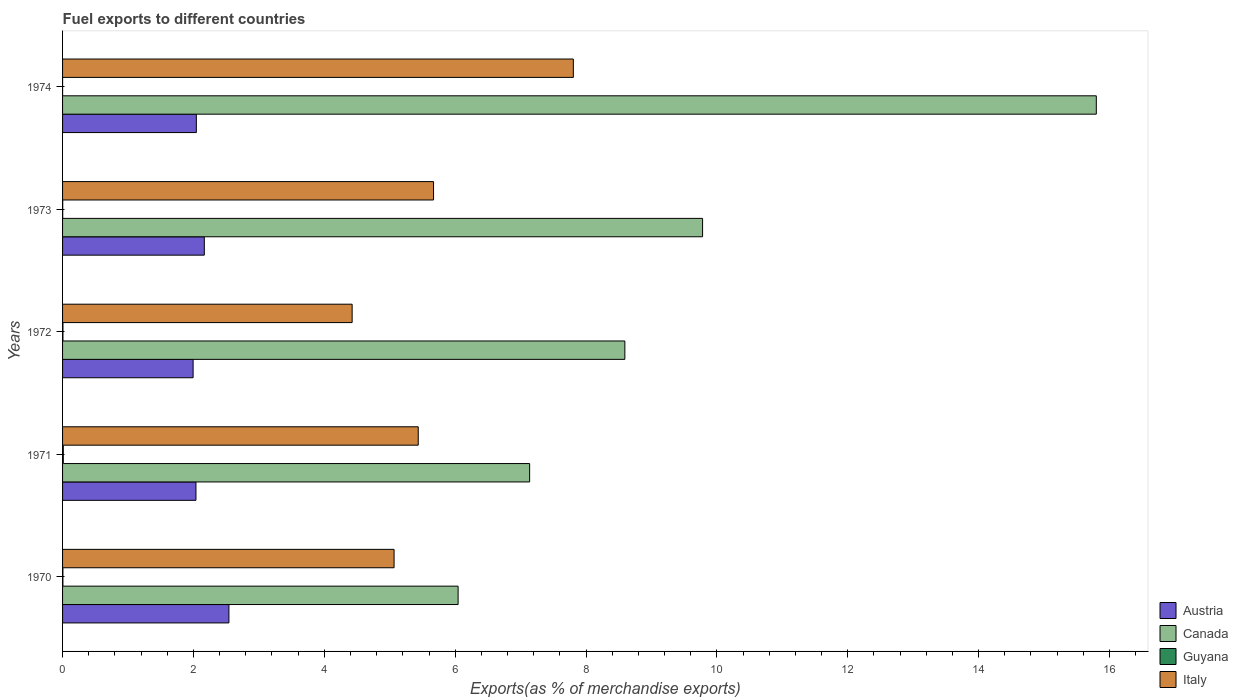How many bars are there on the 5th tick from the bottom?
Provide a succinct answer. 4. What is the percentage of exports to different countries in Austria in 1970?
Provide a succinct answer. 2.54. Across all years, what is the maximum percentage of exports to different countries in Canada?
Your answer should be very brief. 15.8. Across all years, what is the minimum percentage of exports to different countries in Italy?
Your answer should be compact. 4.43. In which year was the percentage of exports to different countries in Canada maximum?
Your response must be concise. 1974. What is the total percentage of exports to different countries in Guyana in the graph?
Keep it short and to the point. 0.02. What is the difference between the percentage of exports to different countries in Austria in 1972 and that in 1973?
Offer a very short reply. -0.17. What is the difference between the percentage of exports to different countries in Canada in 1974 and the percentage of exports to different countries in Italy in 1972?
Your answer should be compact. 11.37. What is the average percentage of exports to different countries in Austria per year?
Make the answer very short. 2.16. In the year 1973, what is the difference between the percentage of exports to different countries in Canada and percentage of exports to different countries in Austria?
Offer a terse response. 7.61. What is the ratio of the percentage of exports to different countries in Guyana in 1972 to that in 1973?
Provide a short and direct response. 2.67. Is the difference between the percentage of exports to different countries in Canada in 1972 and 1974 greater than the difference between the percentage of exports to different countries in Austria in 1972 and 1974?
Offer a terse response. No. What is the difference between the highest and the second highest percentage of exports to different countries in Italy?
Keep it short and to the point. 2.14. What is the difference between the highest and the lowest percentage of exports to different countries in Austria?
Provide a short and direct response. 0.55. Is the sum of the percentage of exports to different countries in Canada in 1971 and 1974 greater than the maximum percentage of exports to different countries in Guyana across all years?
Your answer should be compact. Yes. Is it the case that in every year, the sum of the percentage of exports to different countries in Canada and percentage of exports to different countries in Austria is greater than the sum of percentage of exports to different countries in Italy and percentage of exports to different countries in Guyana?
Your answer should be compact. Yes. What does the 4th bar from the top in 1974 represents?
Ensure brevity in your answer.  Austria. Is it the case that in every year, the sum of the percentage of exports to different countries in Austria and percentage of exports to different countries in Canada is greater than the percentage of exports to different countries in Italy?
Provide a succinct answer. Yes. How many bars are there?
Your answer should be compact. 20. Are all the bars in the graph horizontal?
Your answer should be compact. Yes. How many years are there in the graph?
Offer a terse response. 5. What is the difference between two consecutive major ticks on the X-axis?
Provide a short and direct response. 2. Does the graph contain any zero values?
Your response must be concise. No. Does the graph contain grids?
Make the answer very short. No. How are the legend labels stacked?
Your answer should be very brief. Vertical. What is the title of the graph?
Make the answer very short. Fuel exports to different countries. What is the label or title of the X-axis?
Your answer should be compact. Exports(as % of merchandise exports). What is the Exports(as % of merchandise exports) of Austria in 1970?
Keep it short and to the point. 2.54. What is the Exports(as % of merchandise exports) in Canada in 1970?
Provide a succinct answer. 6.04. What is the Exports(as % of merchandise exports) of Guyana in 1970?
Provide a succinct answer. 0.01. What is the Exports(as % of merchandise exports) in Italy in 1970?
Your answer should be compact. 5.07. What is the Exports(as % of merchandise exports) in Austria in 1971?
Keep it short and to the point. 2.04. What is the Exports(as % of merchandise exports) in Canada in 1971?
Provide a short and direct response. 7.14. What is the Exports(as % of merchandise exports) in Guyana in 1971?
Provide a succinct answer. 0.01. What is the Exports(as % of merchandise exports) of Italy in 1971?
Your response must be concise. 5.44. What is the Exports(as % of merchandise exports) of Austria in 1972?
Offer a very short reply. 1.99. What is the Exports(as % of merchandise exports) in Canada in 1972?
Offer a terse response. 8.59. What is the Exports(as % of merchandise exports) in Guyana in 1972?
Your answer should be very brief. 0.01. What is the Exports(as % of merchandise exports) of Italy in 1972?
Offer a terse response. 4.43. What is the Exports(as % of merchandise exports) in Austria in 1973?
Ensure brevity in your answer.  2.17. What is the Exports(as % of merchandise exports) in Canada in 1973?
Offer a very short reply. 9.78. What is the Exports(as % of merchandise exports) of Guyana in 1973?
Your response must be concise. 0. What is the Exports(as % of merchandise exports) of Italy in 1973?
Your answer should be compact. 5.67. What is the Exports(as % of merchandise exports) in Austria in 1974?
Your answer should be compact. 2.04. What is the Exports(as % of merchandise exports) in Canada in 1974?
Ensure brevity in your answer.  15.8. What is the Exports(as % of merchandise exports) of Guyana in 1974?
Provide a succinct answer. 0. What is the Exports(as % of merchandise exports) of Italy in 1974?
Offer a terse response. 7.81. Across all years, what is the maximum Exports(as % of merchandise exports) in Austria?
Your answer should be very brief. 2.54. Across all years, what is the maximum Exports(as % of merchandise exports) in Canada?
Offer a very short reply. 15.8. Across all years, what is the maximum Exports(as % of merchandise exports) in Guyana?
Give a very brief answer. 0.01. Across all years, what is the maximum Exports(as % of merchandise exports) of Italy?
Offer a terse response. 7.81. Across all years, what is the minimum Exports(as % of merchandise exports) of Austria?
Keep it short and to the point. 1.99. Across all years, what is the minimum Exports(as % of merchandise exports) of Canada?
Keep it short and to the point. 6.04. Across all years, what is the minimum Exports(as % of merchandise exports) in Guyana?
Make the answer very short. 0. Across all years, what is the minimum Exports(as % of merchandise exports) in Italy?
Make the answer very short. 4.43. What is the total Exports(as % of merchandise exports) in Austria in the graph?
Provide a short and direct response. 10.79. What is the total Exports(as % of merchandise exports) of Canada in the graph?
Ensure brevity in your answer.  47.36. What is the total Exports(as % of merchandise exports) in Guyana in the graph?
Make the answer very short. 0.02. What is the total Exports(as % of merchandise exports) of Italy in the graph?
Make the answer very short. 28.4. What is the difference between the Exports(as % of merchandise exports) in Austria in 1970 and that in 1971?
Your answer should be compact. 0.5. What is the difference between the Exports(as % of merchandise exports) in Canada in 1970 and that in 1971?
Your answer should be very brief. -1.09. What is the difference between the Exports(as % of merchandise exports) in Guyana in 1970 and that in 1971?
Offer a very short reply. -0.01. What is the difference between the Exports(as % of merchandise exports) of Italy in 1970 and that in 1971?
Your answer should be compact. -0.37. What is the difference between the Exports(as % of merchandise exports) of Austria in 1970 and that in 1972?
Offer a very short reply. 0.55. What is the difference between the Exports(as % of merchandise exports) in Canada in 1970 and that in 1972?
Ensure brevity in your answer.  -2.55. What is the difference between the Exports(as % of merchandise exports) in Guyana in 1970 and that in 1972?
Your answer should be compact. -0. What is the difference between the Exports(as % of merchandise exports) in Italy in 1970 and that in 1972?
Provide a succinct answer. 0.64. What is the difference between the Exports(as % of merchandise exports) of Austria in 1970 and that in 1973?
Ensure brevity in your answer.  0.38. What is the difference between the Exports(as % of merchandise exports) of Canada in 1970 and that in 1973?
Give a very brief answer. -3.74. What is the difference between the Exports(as % of merchandise exports) of Guyana in 1970 and that in 1973?
Your answer should be compact. 0. What is the difference between the Exports(as % of merchandise exports) in Italy in 1970 and that in 1973?
Offer a very short reply. -0.6. What is the difference between the Exports(as % of merchandise exports) in Austria in 1970 and that in 1974?
Make the answer very short. 0.5. What is the difference between the Exports(as % of merchandise exports) in Canada in 1970 and that in 1974?
Offer a terse response. -9.75. What is the difference between the Exports(as % of merchandise exports) of Guyana in 1970 and that in 1974?
Give a very brief answer. 0.01. What is the difference between the Exports(as % of merchandise exports) in Italy in 1970 and that in 1974?
Ensure brevity in your answer.  -2.74. What is the difference between the Exports(as % of merchandise exports) in Austria in 1971 and that in 1972?
Provide a succinct answer. 0.04. What is the difference between the Exports(as % of merchandise exports) in Canada in 1971 and that in 1972?
Provide a short and direct response. -1.46. What is the difference between the Exports(as % of merchandise exports) of Guyana in 1971 and that in 1972?
Give a very brief answer. 0.01. What is the difference between the Exports(as % of merchandise exports) of Italy in 1971 and that in 1972?
Keep it short and to the point. 1.01. What is the difference between the Exports(as % of merchandise exports) of Austria in 1971 and that in 1973?
Ensure brevity in your answer.  -0.13. What is the difference between the Exports(as % of merchandise exports) of Canada in 1971 and that in 1973?
Provide a short and direct response. -2.64. What is the difference between the Exports(as % of merchandise exports) in Guyana in 1971 and that in 1973?
Your answer should be very brief. 0.01. What is the difference between the Exports(as % of merchandise exports) of Italy in 1971 and that in 1973?
Provide a short and direct response. -0.23. What is the difference between the Exports(as % of merchandise exports) of Austria in 1971 and that in 1974?
Ensure brevity in your answer.  -0.01. What is the difference between the Exports(as % of merchandise exports) of Canada in 1971 and that in 1974?
Provide a succinct answer. -8.66. What is the difference between the Exports(as % of merchandise exports) in Guyana in 1971 and that in 1974?
Offer a very short reply. 0.01. What is the difference between the Exports(as % of merchandise exports) of Italy in 1971 and that in 1974?
Your answer should be very brief. -2.37. What is the difference between the Exports(as % of merchandise exports) of Austria in 1972 and that in 1973?
Ensure brevity in your answer.  -0.17. What is the difference between the Exports(as % of merchandise exports) in Canada in 1972 and that in 1973?
Provide a short and direct response. -1.19. What is the difference between the Exports(as % of merchandise exports) in Guyana in 1972 and that in 1973?
Provide a succinct answer. 0. What is the difference between the Exports(as % of merchandise exports) in Italy in 1972 and that in 1973?
Keep it short and to the point. -1.24. What is the difference between the Exports(as % of merchandise exports) in Austria in 1972 and that in 1974?
Make the answer very short. -0.05. What is the difference between the Exports(as % of merchandise exports) in Canada in 1972 and that in 1974?
Your answer should be very brief. -7.21. What is the difference between the Exports(as % of merchandise exports) in Guyana in 1972 and that in 1974?
Provide a succinct answer. 0.01. What is the difference between the Exports(as % of merchandise exports) of Italy in 1972 and that in 1974?
Provide a short and direct response. -3.38. What is the difference between the Exports(as % of merchandise exports) in Austria in 1973 and that in 1974?
Your response must be concise. 0.12. What is the difference between the Exports(as % of merchandise exports) in Canada in 1973 and that in 1974?
Give a very brief answer. -6.02. What is the difference between the Exports(as % of merchandise exports) of Guyana in 1973 and that in 1974?
Give a very brief answer. 0. What is the difference between the Exports(as % of merchandise exports) of Italy in 1973 and that in 1974?
Offer a terse response. -2.14. What is the difference between the Exports(as % of merchandise exports) in Austria in 1970 and the Exports(as % of merchandise exports) in Canada in 1971?
Ensure brevity in your answer.  -4.6. What is the difference between the Exports(as % of merchandise exports) in Austria in 1970 and the Exports(as % of merchandise exports) in Guyana in 1971?
Make the answer very short. 2.53. What is the difference between the Exports(as % of merchandise exports) in Austria in 1970 and the Exports(as % of merchandise exports) in Italy in 1971?
Your answer should be compact. -2.89. What is the difference between the Exports(as % of merchandise exports) of Canada in 1970 and the Exports(as % of merchandise exports) of Guyana in 1971?
Give a very brief answer. 6.03. What is the difference between the Exports(as % of merchandise exports) in Canada in 1970 and the Exports(as % of merchandise exports) in Italy in 1971?
Your response must be concise. 0.61. What is the difference between the Exports(as % of merchandise exports) in Guyana in 1970 and the Exports(as % of merchandise exports) in Italy in 1971?
Offer a very short reply. -5.43. What is the difference between the Exports(as % of merchandise exports) of Austria in 1970 and the Exports(as % of merchandise exports) of Canada in 1972?
Provide a succinct answer. -6.05. What is the difference between the Exports(as % of merchandise exports) in Austria in 1970 and the Exports(as % of merchandise exports) in Guyana in 1972?
Ensure brevity in your answer.  2.54. What is the difference between the Exports(as % of merchandise exports) in Austria in 1970 and the Exports(as % of merchandise exports) in Italy in 1972?
Offer a terse response. -1.88. What is the difference between the Exports(as % of merchandise exports) of Canada in 1970 and the Exports(as % of merchandise exports) of Guyana in 1972?
Offer a very short reply. 6.04. What is the difference between the Exports(as % of merchandise exports) in Canada in 1970 and the Exports(as % of merchandise exports) in Italy in 1972?
Offer a terse response. 1.62. What is the difference between the Exports(as % of merchandise exports) in Guyana in 1970 and the Exports(as % of merchandise exports) in Italy in 1972?
Provide a succinct answer. -4.42. What is the difference between the Exports(as % of merchandise exports) of Austria in 1970 and the Exports(as % of merchandise exports) of Canada in 1973?
Provide a short and direct response. -7.24. What is the difference between the Exports(as % of merchandise exports) in Austria in 1970 and the Exports(as % of merchandise exports) in Guyana in 1973?
Ensure brevity in your answer.  2.54. What is the difference between the Exports(as % of merchandise exports) of Austria in 1970 and the Exports(as % of merchandise exports) of Italy in 1973?
Offer a very short reply. -3.13. What is the difference between the Exports(as % of merchandise exports) in Canada in 1970 and the Exports(as % of merchandise exports) in Guyana in 1973?
Make the answer very short. 6.04. What is the difference between the Exports(as % of merchandise exports) in Canada in 1970 and the Exports(as % of merchandise exports) in Italy in 1973?
Keep it short and to the point. 0.38. What is the difference between the Exports(as % of merchandise exports) of Guyana in 1970 and the Exports(as % of merchandise exports) of Italy in 1973?
Offer a very short reply. -5.66. What is the difference between the Exports(as % of merchandise exports) of Austria in 1970 and the Exports(as % of merchandise exports) of Canada in 1974?
Provide a succinct answer. -13.26. What is the difference between the Exports(as % of merchandise exports) in Austria in 1970 and the Exports(as % of merchandise exports) in Guyana in 1974?
Make the answer very short. 2.54. What is the difference between the Exports(as % of merchandise exports) of Austria in 1970 and the Exports(as % of merchandise exports) of Italy in 1974?
Offer a very short reply. -5.26. What is the difference between the Exports(as % of merchandise exports) in Canada in 1970 and the Exports(as % of merchandise exports) in Guyana in 1974?
Provide a succinct answer. 6.04. What is the difference between the Exports(as % of merchandise exports) in Canada in 1970 and the Exports(as % of merchandise exports) in Italy in 1974?
Keep it short and to the point. -1.76. What is the difference between the Exports(as % of merchandise exports) in Guyana in 1970 and the Exports(as % of merchandise exports) in Italy in 1974?
Offer a very short reply. -7.8. What is the difference between the Exports(as % of merchandise exports) in Austria in 1971 and the Exports(as % of merchandise exports) in Canada in 1972?
Offer a terse response. -6.55. What is the difference between the Exports(as % of merchandise exports) of Austria in 1971 and the Exports(as % of merchandise exports) of Guyana in 1972?
Provide a short and direct response. 2.03. What is the difference between the Exports(as % of merchandise exports) in Austria in 1971 and the Exports(as % of merchandise exports) in Italy in 1972?
Offer a very short reply. -2.39. What is the difference between the Exports(as % of merchandise exports) in Canada in 1971 and the Exports(as % of merchandise exports) in Guyana in 1972?
Offer a terse response. 7.13. What is the difference between the Exports(as % of merchandise exports) in Canada in 1971 and the Exports(as % of merchandise exports) in Italy in 1972?
Your answer should be very brief. 2.71. What is the difference between the Exports(as % of merchandise exports) in Guyana in 1971 and the Exports(as % of merchandise exports) in Italy in 1972?
Ensure brevity in your answer.  -4.41. What is the difference between the Exports(as % of merchandise exports) in Austria in 1971 and the Exports(as % of merchandise exports) in Canada in 1973?
Provide a succinct answer. -7.74. What is the difference between the Exports(as % of merchandise exports) of Austria in 1971 and the Exports(as % of merchandise exports) of Guyana in 1973?
Ensure brevity in your answer.  2.04. What is the difference between the Exports(as % of merchandise exports) of Austria in 1971 and the Exports(as % of merchandise exports) of Italy in 1973?
Offer a terse response. -3.63. What is the difference between the Exports(as % of merchandise exports) in Canada in 1971 and the Exports(as % of merchandise exports) in Guyana in 1973?
Ensure brevity in your answer.  7.14. What is the difference between the Exports(as % of merchandise exports) of Canada in 1971 and the Exports(as % of merchandise exports) of Italy in 1973?
Keep it short and to the point. 1.47. What is the difference between the Exports(as % of merchandise exports) of Guyana in 1971 and the Exports(as % of merchandise exports) of Italy in 1973?
Your answer should be compact. -5.66. What is the difference between the Exports(as % of merchandise exports) in Austria in 1971 and the Exports(as % of merchandise exports) in Canada in 1974?
Keep it short and to the point. -13.76. What is the difference between the Exports(as % of merchandise exports) in Austria in 1971 and the Exports(as % of merchandise exports) in Guyana in 1974?
Provide a short and direct response. 2.04. What is the difference between the Exports(as % of merchandise exports) in Austria in 1971 and the Exports(as % of merchandise exports) in Italy in 1974?
Your answer should be compact. -5.77. What is the difference between the Exports(as % of merchandise exports) of Canada in 1971 and the Exports(as % of merchandise exports) of Guyana in 1974?
Keep it short and to the point. 7.14. What is the difference between the Exports(as % of merchandise exports) in Canada in 1971 and the Exports(as % of merchandise exports) in Italy in 1974?
Make the answer very short. -0.67. What is the difference between the Exports(as % of merchandise exports) in Guyana in 1971 and the Exports(as % of merchandise exports) in Italy in 1974?
Your answer should be compact. -7.79. What is the difference between the Exports(as % of merchandise exports) of Austria in 1972 and the Exports(as % of merchandise exports) of Canada in 1973?
Offer a very short reply. -7.79. What is the difference between the Exports(as % of merchandise exports) of Austria in 1972 and the Exports(as % of merchandise exports) of Guyana in 1973?
Keep it short and to the point. 1.99. What is the difference between the Exports(as % of merchandise exports) of Austria in 1972 and the Exports(as % of merchandise exports) of Italy in 1973?
Your answer should be compact. -3.67. What is the difference between the Exports(as % of merchandise exports) in Canada in 1972 and the Exports(as % of merchandise exports) in Guyana in 1973?
Your answer should be compact. 8.59. What is the difference between the Exports(as % of merchandise exports) of Canada in 1972 and the Exports(as % of merchandise exports) of Italy in 1973?
Ensure brevity in your answer.  2.92. What is the difference between the Exports(as % of merchandise exports) of Guyana in 1972 and the Exports(as % of merchandise exports) of Italy in 1973?
Your answer should be compact. -5.66. What is the difference between the Exports(as % of merchandise exports) in Austria in 1972 and the Exports(as % of merchandise exports) in Canada in 1974?
Offer a very short reply. -13.8. What is the difference between the Exports(as % of merchandise exports) in Austria in 1972 and the Exports(as % of merchandise exports) in Guyana in 1974?
Give a very brief answer. 1.99. What is the difference between the Exports(as % of merchandise exports) in Austria in 1972 and the Exports(as % of merchandise exports) in Italy in 1974?
Keep it short and to the point. -5.81. What is the difference between the Exports(as % of merchandise exports) in Canada in 1972 and the Exports(as % of merchandise exports) in Guyana in 1974?
Ensure brevity in your answer.  8.59. What is the difference between the Exports(as % of merchandise exports) of Canada in 1972 and the Exports(as % of merchandise exports) of Italy in 1974?
Give a very brief answer. 0.79. What is the difference between the Exports(as % of merchandise exports) in Austria in 1973 and the Exports(as % of merchandise exports) in Canada in 1974?
Offer a terse response. -13.63. What is the difference between the Exports(as % of merchandise exports) in Austria in 1973 and the Exports(as % of merchandise exports) in Guyana in 1974?
Provide a short and direct response. 2.17. What is the difference between the Exports(as % of merchandise exports) in Austria in 1973 and the Exports(as % of merchandise exports) in Italy in 1974?
Offer a terse response. -5.64. What is the difference between the Exports(as % of merchandise exports) in Canada in 1973 and the Exports(as % of merchandise exports) in Guyana in 1974?
Your answer should be compact. 9.78. What is the difference between the Exports(as % of merchandise exports) of Canada in 1973 and the Exports(as % of merchandise exports) of Italy in 1974?
Offer a terse response. 1.98. What is the difference between the Exports(as % of merchandise exports) in Guyana in 1973 and the Exports(as % of merchandise exports) in Italy in 1974?
Provide a succinct answer. -7.8. What is the average Exports(as % of merchandise exports) in Austria per year?
Give a very brief answer. 2.16. What is the average Exports(as % of merchandise exports) of Canada per year?
Offer a terse response. 9.47. What is the average Exports(as % of merchandise exports) in Guyana per year?
Offer a very short reply. 0.01. What is the average Exports(as % of merchandise exports) in Italy per year?
Offer a very short reply. 5.68. In the year 1970, what is the difference between the Exports(as % of merchandise exports) of Austria and Exports(as % of merchandise exports) of Canada?
Keep it short and to the point. -3.5. In the year 1970, what is the difference between the Exports(as % of merchandise exports) of Austria and Exports(as % of merchandise exports) of Guyana?
Your answer should be very brief. 2.54. In the year 1970, what is the difference between the Exports(as % of merchandise exports) in Austria and Exports(as % of merchandise exports) in Italy?
Your answer should be compact. -2.52. In the year 1970, what is the difference between the Exports(as % of merchandise exports) of Canada and Exports(as % of merchandise exports) of Guyana?
Your answer should be compact. 6.04. In the year 1970, what is the difference between the Exports(as % of merchandise exports) in Canada and Exports(as % of merchandise exports) in Italy?
Keep it short and to the point. 0.98. In the year 1970, what is the difference between the Exports(as % of merchandise exports) of Guyana and Exports(as % of merchandise exports) of Italy?
Make the answer very short. -5.06. In the year 1971, what is the difference between the Exports(as % of merchandise exports) in Austria and Exports(as % of merchandise exports) in Canada?
Ensure brevity in your answer.  -5.1. In the year 1971, what is the difference between the Exports(as % of merchandise exports) of Austria and Exports(as % of merchandise exports) of Guyana?
Offer a very short reply. 2.03. In the year 1971, what is the difference between the Exports(as % of merchandise exports) in Austria and Exports(as % of merchandise exports) in Italy?
Provide a short and direct response. -3.4. In the year 1971, what is the difference between the Exports(as % of merchandise exports) of Canada and Exports(as % of merchandise exports) of Guyana?
Your answer should be compact. 7.13. In the year 1971, what is the difference between the Exports(as % of merchandise exports) of Canada and Exports(as % of merchandise exports) of Italy?
Provide a succinct answer. 1.7. In the year 1971, what is the difference between the Exports(as % of merchandise exports) of Guyana and Exports(as % of merchandise exports) of Italy?
Provide a succinct answer. -5.42. In the year 1972, what is the difference between the Exports(as % of merchandise exports) in Austria and Exports(as % of merchandise exports) in Canada?
Provide a short and direct response. -6.6. In the year 1972, what is the difference between the Exports(as % of merchandise exports) of Austria and Exports(as % of merchandise exports) of Guyana?
Give a very brief answer. 1.99. In the year 1972, what is the difference between the Exports(as % of merchandise exports) in Austria and Exports(as % of merchandise exports) in Italy?
Your answer should be compact. -2.43. In the year 1972, what is the difference between the Exports(as % of merchandise exports) of Canada and Exports(as % of merchandise exports) of Guyana?
Keep it short and to the point. 8.59. In the year 1972, what is the difference between the Exports(as % of merchandise exports) of Canada and Exports(as % of merchandise exports) of Italy?
Ensure brevity in your answer.  4.17. In the year 1972, what is the difference between the Exports(as % of merchandise exports) in Guyana and Exports(as % of merchandise exports) in Italy?
Ensure brevity in your answer.  -4.42. In the year 1973, what is the difference between the Exports(as % of merchandise exports) in Austria and Exports(as % of merchandise exports) in Canada?
Your answer should be compact. -7.61. In the year 1973, what is the difference between the Exports(as % of merchandise exports) of Austria and Exports(as % of merchandise exports) of Guyana?
Your answer should be compact. 2.16. In the year 1973, what is the difference between the Exports(as % of merchandise exports) of Austria and Exports(as % of merchandise exports) of Italy?
Provide a short and direct response. -3.5. In the year 1973, what is the difference between the Exports(as % of merchandise exports) in Canada and Exports(as % of merchandise exports) in Guyana?
Provide a succinct answer. 9.78. In the year 1973, what is the difference between the Exports(as % of merchandise exports) of Canada and Exports(as % of merchandise exports) of Italy?
Provide a short and direct response. 4.11. In the year 1973, what is the difference between the Exports(as % of merchandise exports) in Guyana and Exports(as % of merchandise exports) in Italy?
Your answer should be very brief. -5.67. In the year 1974, what is the difference between the Exports(as % of merchandise exports) in Austria and Exports(as % of merchandise exports) in Canada?
Your answer should be compact. -13.75. In the year 1974, what is the difference between the Exports(as % of merchandise exports) of Austria and Exports(as % of merchandise exports) of Guyana?
Provide a short and direct response. 2.04. In the year 1974, what is the difference between the Exports(as % of merchandise exports) in Austria and Exports(as % of merchandise exports) in Italy?
Your response must be concise. -5.76. In the year 1974, what is the difference between the Exports(as % of merchandise exports) of Canada and Exports(as % of merchandise exports) of Guyana?
Keep it short and to the point. 15.8. In the year 1974, what is the difference between the Exports(as % of merchandise exports) of Canada and Exports(as % of merchandise exports) of Italy?
Make the answer very short. 7.99. In the year 1974, what is the difference between the Exports(as % of merchandise exports) in Guyana and Exports(as % of merchandise exports) in Italy?
Ensure brevity in your answer.  -7.81. What is the ratio of the Exports(as % of merchandise exports) of Austria in 1970 to that in 1971?
Offer a very short reply. 1.25. What is the ratio of the Exports(as % of merchandise exports) of Canada in 1970 to that in 1971?
Your answer should be very brief. 0.85. What is the ratio of the Exports(as % of merchandise exports) in Guyana in 1970 to that in 1971?
Give a very brief answer. 0.46. What is the ratio of the Exports(as % of merchandise exports) in Italy in 1970 to that in 1971?
Your answer should be very brief. 0.93. What is the ratio of the Exports(as % of merchandise exports) of Austria in 1970 to that in 1972?
Give a very brief answer. 1.27. What is the ratio of the Exports(as % of merchandise exports) in Canada in 1970 to that in 1972?
Ensure brevity in your answer.  0.7. What is the ratio of the Exports(as % of merchandise exports) of Guyana in 1970 to that in 1972?
Provide a short and direct response. 0.86. What is the ratio of the Exports(as % of merchandise exports) in Italy in 1970 to that in 1972?
Offer a very short reply. 1.14. What is the ratio of the Exports(as % of merchandise exports) in Austria in 1970 to that in 1973?
Your response must be concise. 1.17. What is the ratio of the Exports(as % of merchandise exports) of Canada in 1970 to that in 1973?
Ensure brevity in your answer.  0.62. What is the ratio of the Exports(as % of merchandise exports) in Guyana in 1970 to that in 1973?
Offer a very short reply. 2.29. What is the ratio of the Exports(as % of merchandise exports) in Italy in 1970 to that in 1973?
Make the answer very short. 0.89. What is the ratio of the Exports(as % of merchandise exports) of Austria in 1970 to that in 1974?
Provide a short and direct response. 1.24. What is the ratio of the Exports(as % of merchandise exports) of Canada in 1970 to that in 1974?
Your response must be concise. 0.38. What is the ratio of the Exports(as % of merchandise exports) in Guyana in 1970 to that in 1974?
Your response must be concise. 24.45. What is the ratio of the Exports(as % of merchandise exports) in Italy in 1970 to that in 1974?
Provide a short and direct response. 0.65. What is the ratio of the Exports(as % of merchandise exports) of Austria in 1971 to that in 1972?
Your answer should be compact. 1.02. What is the ratio of the Exports(as % of merchandise exports) of Canada in 1971 to that in 1972?
Offer a terse response. 0.83. What is the ratio of the Exports(as % of merchandise exports) in Guyana in 1971 to that in 1972?
Make the answer very short. 1.88. What is the ratio of the Exports(as % of merchandise exports) of Italy in 1971 to that in 1972?
Ensure brevity in your answer.  1.23. What is the ratio of the Exports(as % of merchandise exports) of Austria in 1971 to that in 1973?
Your response must be concise. 0.94. What is the ratio of the Exports(as % of merchandise exports) in Canada in 1971 to that in 1973?
Your response must be concise. 0.73. What is the ratio of the Exports(as % of merchandise exports) in Guyana in 1971 to that in 1973?
Your answer should be compact. 5. What is the ratio of the Exports(as % of merchandise exports) of Italy in 1971 to that in 1973?
Your response must be concise. 0.96. What is the ratio of the Exports(as % of merchandise exports) of Canada in 1971 to that in 1974?
Make the answer very short. 0.45. What is the ratio of the Exports(as % of merchandise exports) in Guyana in 1971 to that in 1974?
Make the answer very short. 53.37. What is the ratio of the Exports(as % of merchandise exports) in Italy in 1971 to that in 1974?
Ensure brevity in your answer.  0.7. What is the ratio of the Exports(as % of merchandise exports) in Austria in 1972 to that in 1973?
Provide a succinct answer. 0.92. What is the ratio of the Exports(as % of merchandise exports) of Canada in 1972 to that in 1973?
Ensure brevity in your answer.  0.88. What is the ratio of the Exports(as % of merchandise exports) in Guyana in 1972 to that in 1973?
Provide a short and direct response. 2.67. What is the ratio of the Exports(as % of merchandise exports) in Italy in 1972 to that in 1973?
Provide a short and direct response. 0.78. What is the ratio of the Exports(as % of merchandise exports) in Austria in 1972 to that in 1974?
Provide a succinct answer. 0.98. What is the ratio of the Exports(as % of merchandise exports) of Canada in 1972 to that in 1974?
Your response must be concise. 0.54. What is the ratio of the Exports(as % of merchandise exports) in Guyana in 1972 to that in 1974?
Your answer should be compact. 28.43. What is the ratio of the Exports(as % of merchandise exports) of Italy in 1972 to that in 1974?
Offer a very short reply. 0.57. What is the ratio of the Exports(as % of merchandise exports) of Austria in 1973 to that in 1974?
Keep it short and to the point. 1.06. What is the ratio of the Exports(as % of merchandise exports) in Canada in 1973 to that in 1974?
Give a very brief answer. 0.62. What is the ratio of the Exports(as % of merchandise exports) of Guyana in 1973 to that in 1974?
Provide a succinct answer. 10.67. What is the ratio of the Exports(as % of merchandise exports) of Italy in 1973 to that in 1974?
Ensure brevity in your answer.  0.73. What is the difference between the highest and the second highest Exports(as % of merchandise exports) of Austria?
Your response must be concise. 0.38. What is the difference between the highest and the second highest Exports(as % of merchandise exports) of Canada?
Your answer should be very brief. 6.02. What is the difference between the highest and the second highest Exports(as % of merchandise exports) of Guyana?
Keep it short and to the point. 0.01. What is the difference between the highest and the second highest Exports(as % of merchandise exports) in Italy?
Your answer should be very brief. 2.14. What is the difference between the highest and the lowest Exports(as % of merchandise exports) in Austria?
Make the answer very short. 0.55. What is the difference between the highest and the lowest Exports(as % of merchandise exports) of Canada?
Your answer should be compact. 9.75. What is the difference between the highest and the lowest Exports(as % of merchandise exports) in Guyana?
Your answer should be very brief. 0.01. What is the difference between the highest and the lowest Exports(as % of merchandise exports) of Italy?
Ensure brevity in your answer.  3.38. 